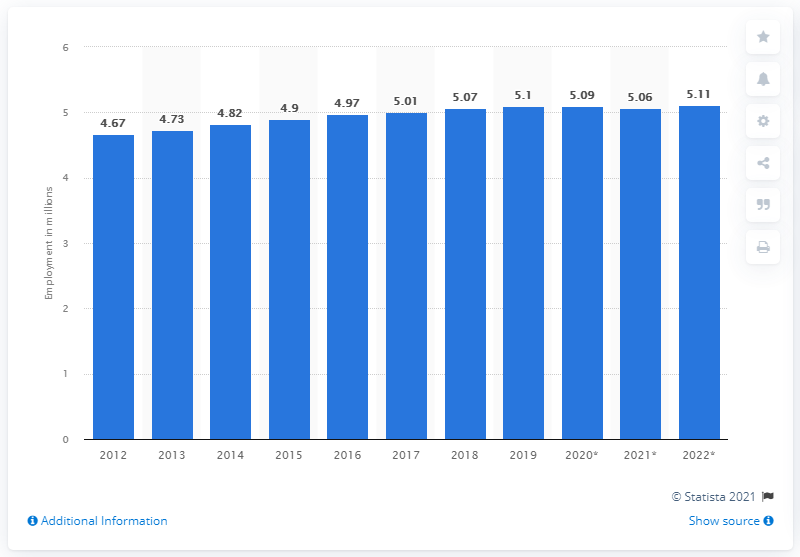Indicate a few pertinent items in this graphic. In 2012, the employment in Switzerland was first reported. In 2019, approximately 5.11 million people were employed in Switzerland. 